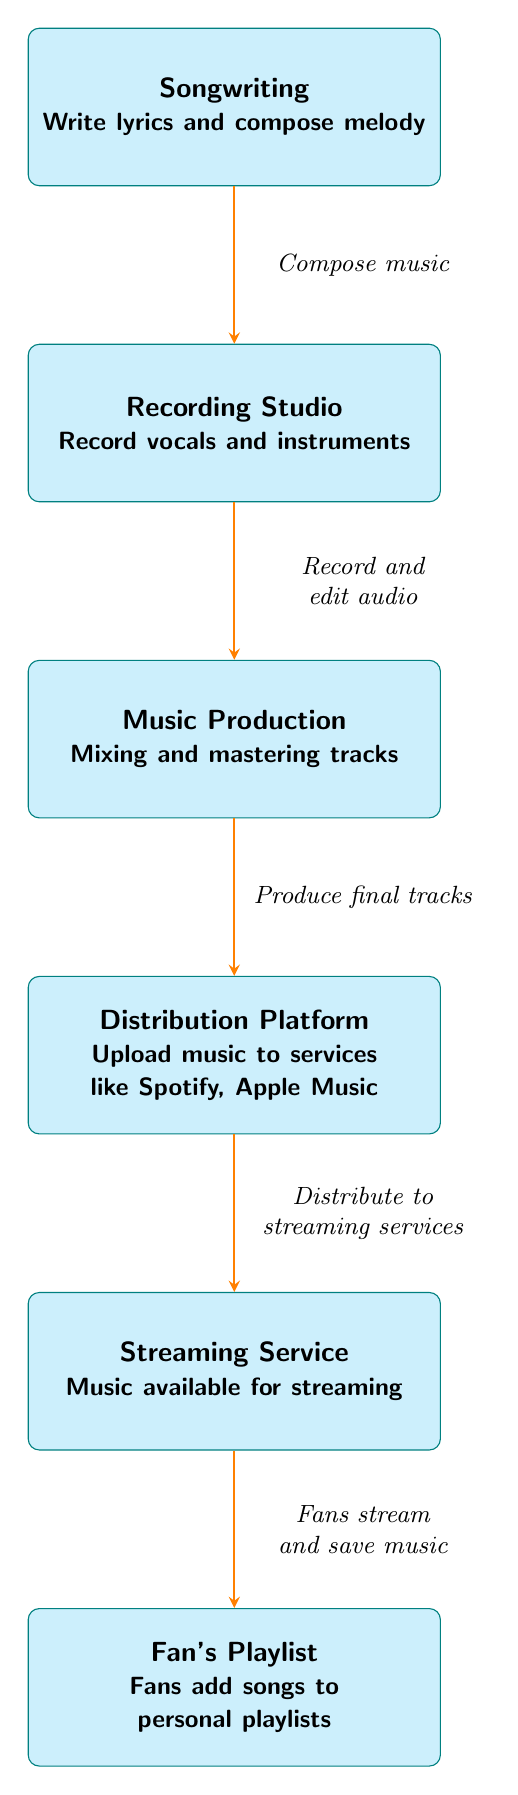What is the first step in the music creation process? The first step listed in the diagram is "Songwriting," which involves writing lyrics and composing melodies.
Answer: Songwriting How many nodes are represented in the diagram? By counting each distinct box in the diagram, there are six nodes representing different stages in the process.
Answer: Six What does the arrow from "Recording Studio" to "Music Production" represent? This arrow signifies the action of "Record and edit audio," indicating that the recording studio stage leads into the music production phase.
Answer: Record and edit audio Which node comes after "Music Production"? According to the flow of the diagram, "Distribution Platform" follows "Music Production" as the next stage in the chain of music creation to consumption.
Answer: Distribution Platform What action do fans take in relation to the "Streaming Service"? The arrow directed from "Streaming Service" to "Fan's Playlist" describes the action where fans stream and save music available on the service.
Answer: Fans stream and save music What is the relationship between "Distribution Platform" and "Streaming Service"? The relationship is defined by the action of "Distribute to streaming services," where the music distribution connects the earlier production phase to the streaming phase.
Answer: Distribute to streaming services If a song is ready for streaming, which node preceded it? The song ready for streaming comes after "Distribution Platform," meaning it must have been first distributed before it can be available on a streaming service.
Answer: Distribution Platform What is the purpose of "Fan's Playlist" in the diagram? "Fan's Playlist" represents the final step where fans add songs to their personal playlists, thereby indicating their engagement with the music.
Answer: Fans add songs to personal playlists 